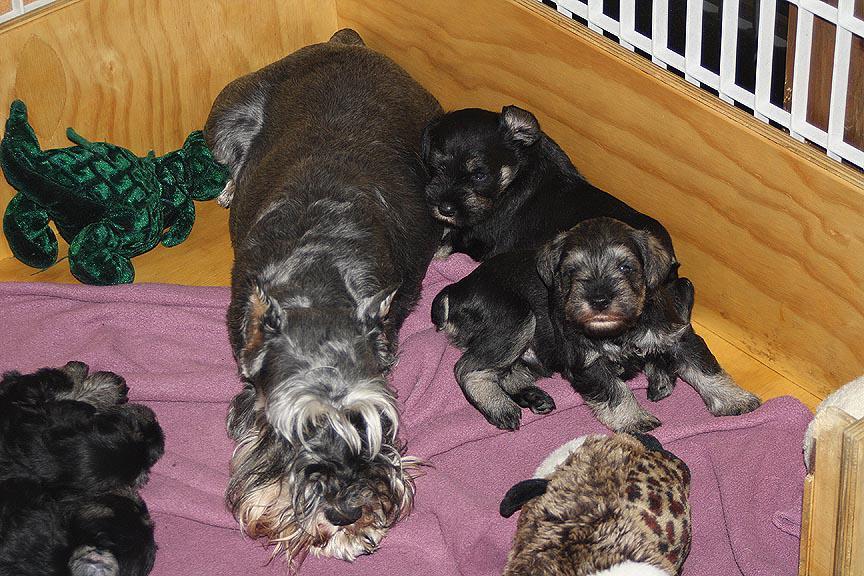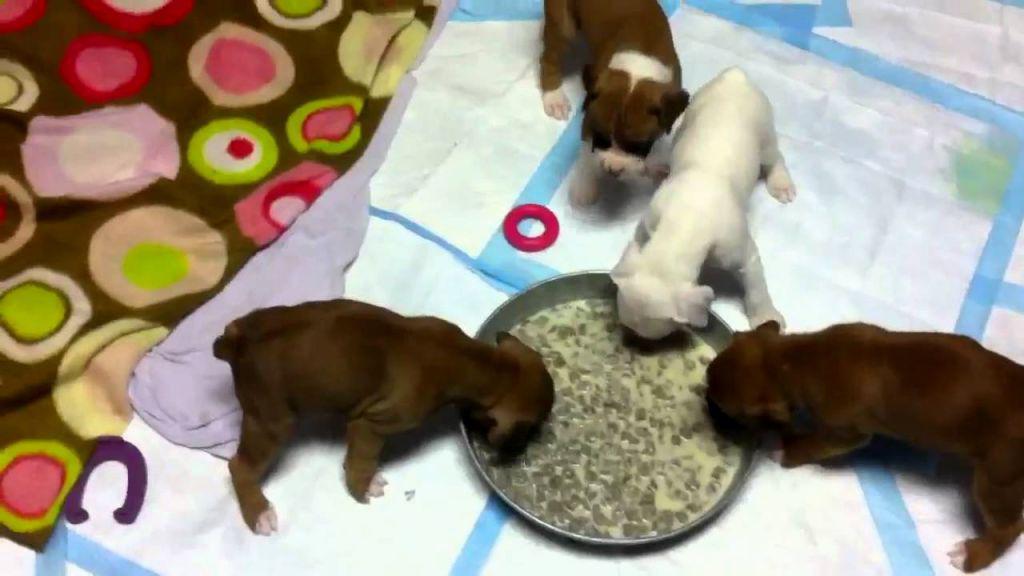The first image is the image on the left, the second image is the image on the right. Analyze the images presented: Is the assertion "An image shows a mother dog in a wood-sided crate with several puppies." valid? Answer yes or no. Yes. The first image is the image on the left, the second image is the image on the right. Analyze the images presented: Is the assertion "A wooden box with pink blankets is full of puppies" valid? Answer yes or no. Yes. 